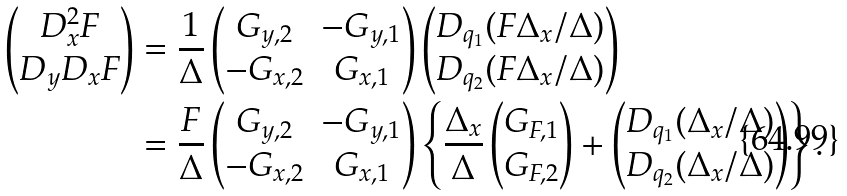<formula> <loc_0><loc_0><loc_500><loc_500>\begin{pmatrix} D _ { x } ^ { 2 } F \\ D _ { y } D _ { x } F \end{pmatrix} & = \frac { 1 } { \Delta } \begin{pmatrix} G _ { y , 2 } & - G _ { y , 1 } \\ - G _ { x , 2 } & G _ { x , 1 } \end{pmatrix} \begin{pmatrix} D _ { q _ { 1 } } ( F \Delta _ { x } / \Delta ) \\ D _ { q _ { 2 } } ( F \Delta _ { x } / \Delta ) \end{pmatrix} \\ & = \frac { F } { \Delta } \begin{pmatrix} G _ { y , 2 } & - G _ { y , 1 } \\ - G _ { x , 2 } & G _ { x , 1 } \end{pmatrix} \left \{ \frac { \Delta _ { x } } \Delta \begin{pmatrix} G _ { F , 1 } \\ G _ { F , 2 } \end{pmatrix} + \begin{pmatrix} D _ { q _ { 1 } } ( \Delta _ { x } / \Delta ) \\ D _ { q _ { 2 } } ( \Delta _ { x } / \Delta ) \end{pmatrix} \right \} .</formula> 